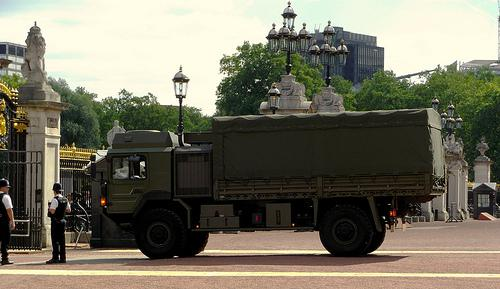Question: who is wearing black?
Choices:
A. The mob.
B. The police men.
C. The mimes.
D. The janitor.
Answer with the letter. Answer: B Question: where was the picture taken?
Choices:
A. At the park.
B. At my house.
C. On the street.
D. On the plane.
Answer with the letter. Answer: C 